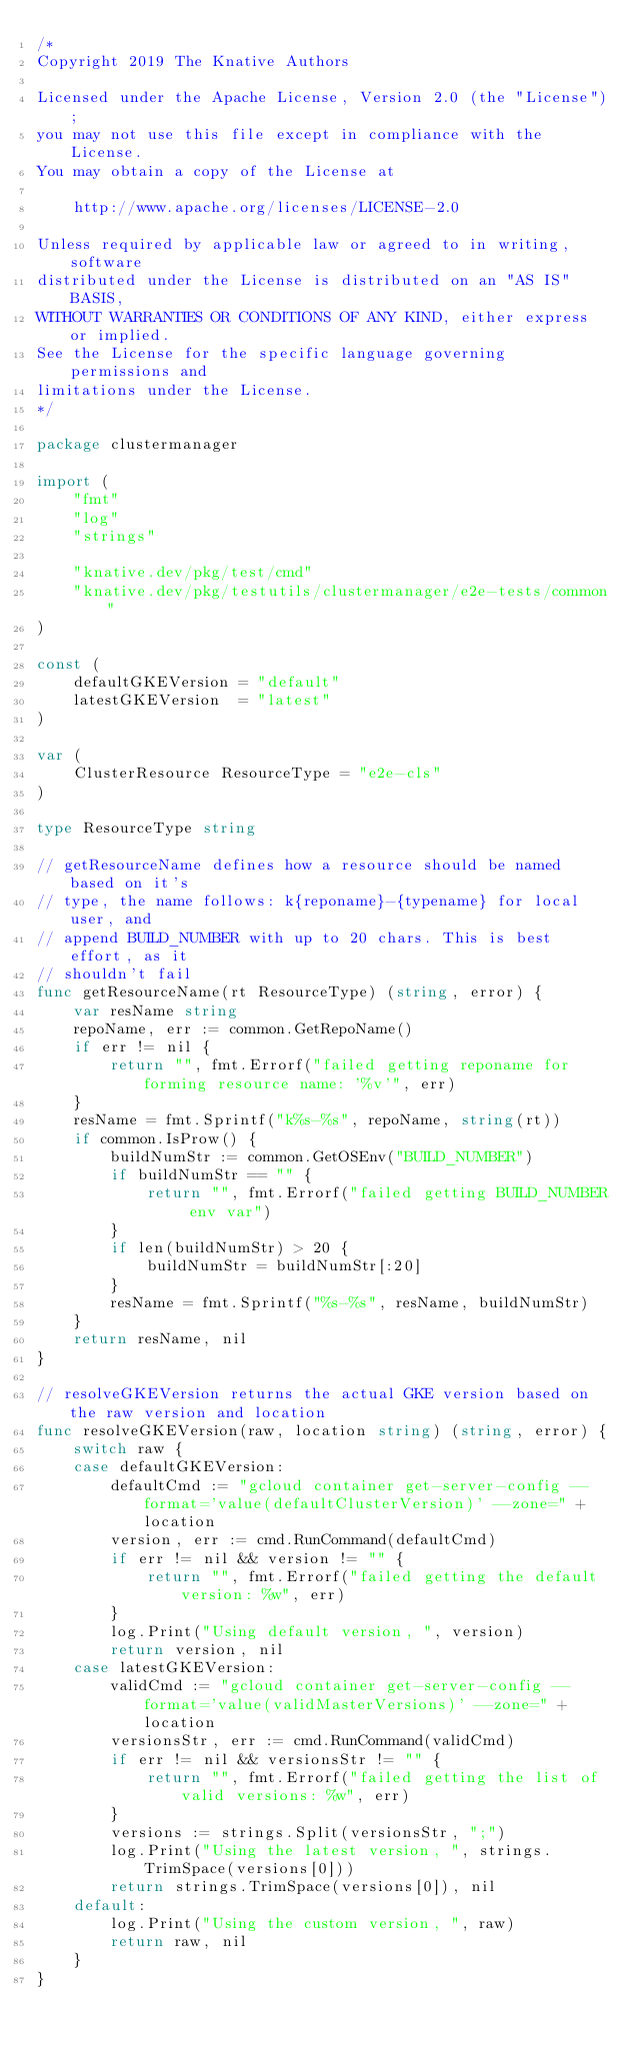<code> <loc_0><loc_0><loc_500><loc_500><_Go_>/*
Copyright 2019 The Knative Authors

Licensed under the Apache License, Version 2.0 (the "License");
you may not use this file except in compliance with the License.
You may obtain a copy of the License at

    http://www.apache.org/licenses/LICENSE-2.0

Unless required by applicable law or agreed to in writing, software
distributed under the License is distributed on an "AS IS" BASIS,
WITHOUT WARRANTIES OR CONDITIONS OF ANY KIND, either express or implied.
See the License for the specific language governing permissions and
limitations under the License.
*/

package clustermanager

import (
	"fmt"
	"log"
	"strings"

	"knative.dev/pkg/test/cmd"
	"knative.dev/pkg/testutils/clustermanager/e2e-tests/common"
)

const (
	defaultGKEVersion = "default"
	latestGKEVersion  = "latest"
)

var (
	ClusterResource ResourceType = "e2e-cls"
)

type ResourceType string

// getResourceName defines how a resource should be named based on it's
// type, the name follows: k{reponame}-{typename} for local user, and
// append BUILD_NUMBER with up to 20 chars. This is best effort, as it
// shouldn't fail
func getResourceName(rt ResourceType) (string, error) {
	var resName string
	repoName, err := common.GetRepoName()
	if err != nil {
		return "", fmt.Errorf("failed getting reponame for forming resource name: '%v'", err)
	}
	resName = fmt.Sprintf("k%s-%s", repoName, string(rt))
	if common.IsProw() {
		buildNumStr := common.GetOSEnv("BUILD_NUMBER")
		if buildNumStr == "" {
			return "", fmt.Errorf("failed getting BUILD_NUMBER env var")
		}
		if len(buildNumStr) > 20 {
			buildNumStr = buildNumStr[:20]
		}
		resName = fmt.Sprintf("%s-%s", resName, buildNumStr)
	}
	return resName, nil
}

// resolveGKEVersion returns the actual GKE version based on the raw version and location
func resolveGKEVersion(raw, location string) (string, error) {
	switch raw {
	case defaultGKEVersion:
		defaultCmd := "gcloud container get-server-config --format='value(defaultClusterVersion)' --zone=" + location
		version, err := cmd.RunCommand(defaultCmd)
		if err != nil && version != "" {
			return "", fmt.Errorf("failed getting the default version: %w", err)
		}
		log.Print("Using default version, ", version)
		return version, nil
	case latestGKEVersion:
		validCmd := "gcloud container get-server-config --format='value(validMasterVersions)' --zone=" + location
		versionsStr, err := cmd.RunCommand(validCmd)
		if err != nil && versionsStr != "" {
			return "", fmt.Errorf("failed getting the list of valid versions: %w", err)
		}
		versions := strings.Split(versionsStr, ";")
		log.Print("Using the latest version, ", strings.TrimSpace(versions[0]))
		return strings.TrimSpace(versions[0]), nil
	default:
		log.Print("Using the custom version, ", raw)
		return raw, nil
	}
}
</code> 